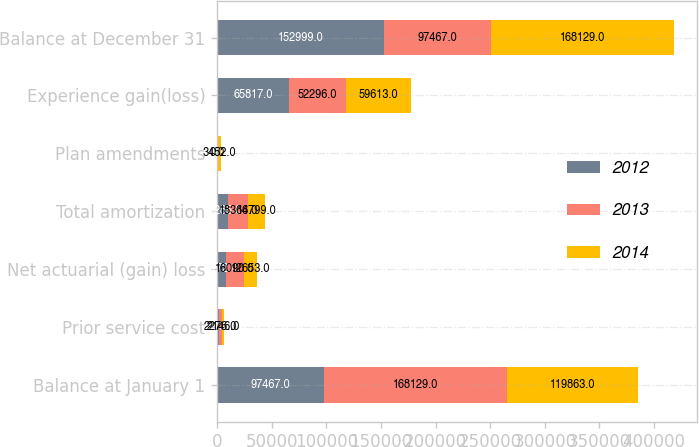<chart> <loc_0><loc_0><loc_500><loc_500><stacked_bar_chart><ecel><fcel>Balance at January 1<fcel>Prior service cost<fcel>Net actuarial (gain) loss<fcel>Total amortization<fcel>Plan amendments<fcel>Experience gain(loss)<fcel>Balance at December 31<nl><fcel>2012<fcel>97467<fcel>2113<fcel>8172<fcel>10285<fcel>0<fcel>65817<fcel>152999<nl><fcel>2013<fcel>168129<fcel>2276<fcel>16090<fcel>18366<fcel>0<fcel>52296<fcel>97467<nl><fcel>2014<fcel>119863<fcel>2146<fcel>12653<fcel>14799<fcel>3452<fcel>59613<fcel>168129<nl></chart> 